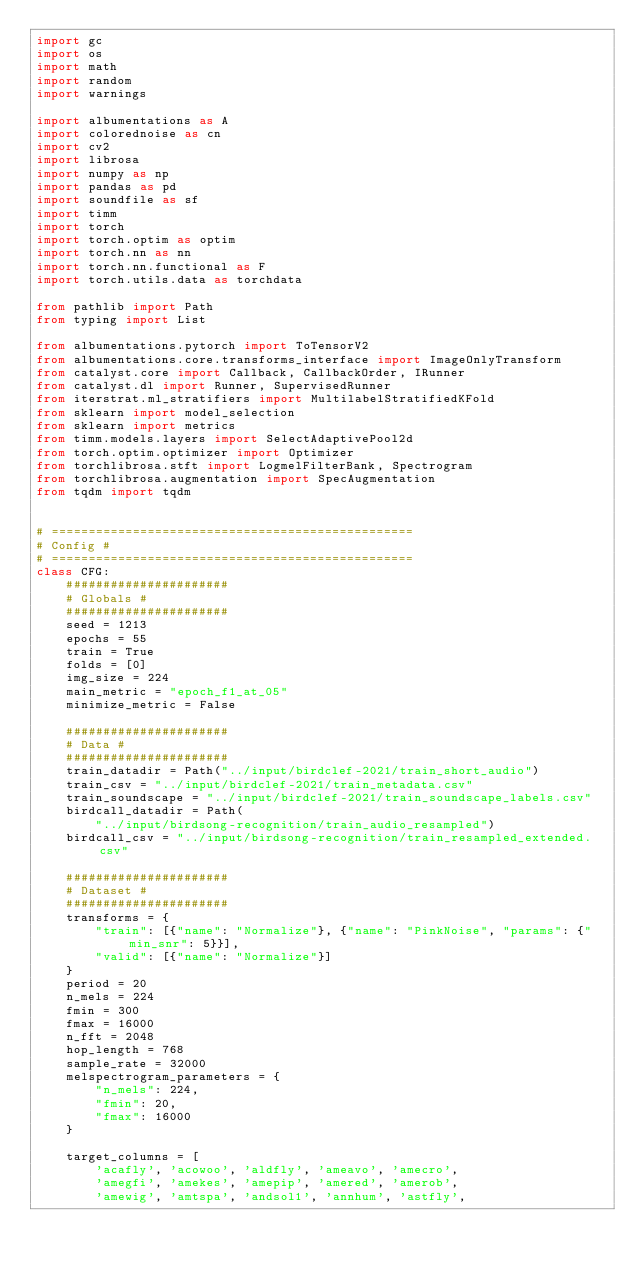<code> <loc_0><loc_0><loc_500><loc_500><_Python_>import gc
import os
import math
import random
import warnings

import albumentations as A
import colorednoise as cn
import cv2
import librosa
import numpy as np
import pandas as pd
import soundfile as sf
import timm
import torch
import torch.optim as optim
import torch.nn as nn
import torch.nn.functional as F
import torch.utils.data as torchdata

from pathlib import Path
from typing import List

from albumentations.pytorch import ToTensorV2
from albumentations.core.transforms_interface import ImageOnlyTransform
from catalyst.core import Callback, CallbackOrder, IRunner
from catalyst.dl import Runner, SupervisedRunner
from iterstrat.ml_stratifiers import MultilabelStratifiedKFold
from sklearn import model_selection
from sklearn import metrics
from timm.models.layers import SelectAdaptivePool2d
from torch.optim.optimizer import Optimizer
from torchlibrosa.stft import LogmelFilterBank, Spectrogram
from torchlibrosa.augmentation import SpecAugmentation
from tqdm import tqdm


# =================================================
# Config #
# =================================================
class CFG:
    ######################
    # Globals #
    ######################
    seed = 1213
    epochs = 55
    train = True
    folds = [0]
    img_size = 224
    main_metric = "epoch_f1_at_05"
    minimize_metric = False

    ######################
    # Data #
    ######################
    train_datadir = Path("../input/birdclef-2021/train_short_audio")
    train_csv = "../input/birdclef-2021/train_metadata.csv"
    train_soundscape = "../input/birdclef-2021/train_soundscape_labels.csv"
    birdcall_datadir = Path(
        "../input/birdsong-recognition/train_audio_resampled")
    birdcall_csv = "../input/birdsong-recognition/train_resampled_extended.csv"

    ######################
    # Dataset #
    ######################
    transforms = {
        "train": [{"name": "Normalize"}, {"name": "PinkNoise", "params": {"min_snr": 5}}],
        "valid": [{"name": "Normalize"}]
    }
    period = 20
    n_mels = 224
    fmin = 300
    fmax = 16000
    n_fft = 2048
    hop_length = 768
    sample_rate = 32000
    melspectrogram_parameters = {
        "n_mels": 224,
        "fmin": 20,
        "fmax": 16000
    }

    target_columns = [
        'acafly', 'acowoo', 'aldfly', 'ameavo', 'amecro',
        'amegfi', 'amekes', 'amepip', 'amered', 'amerob',
        'amewig', 'amtspa', 'andsol1', 'annhum', 'astfly',</code> 